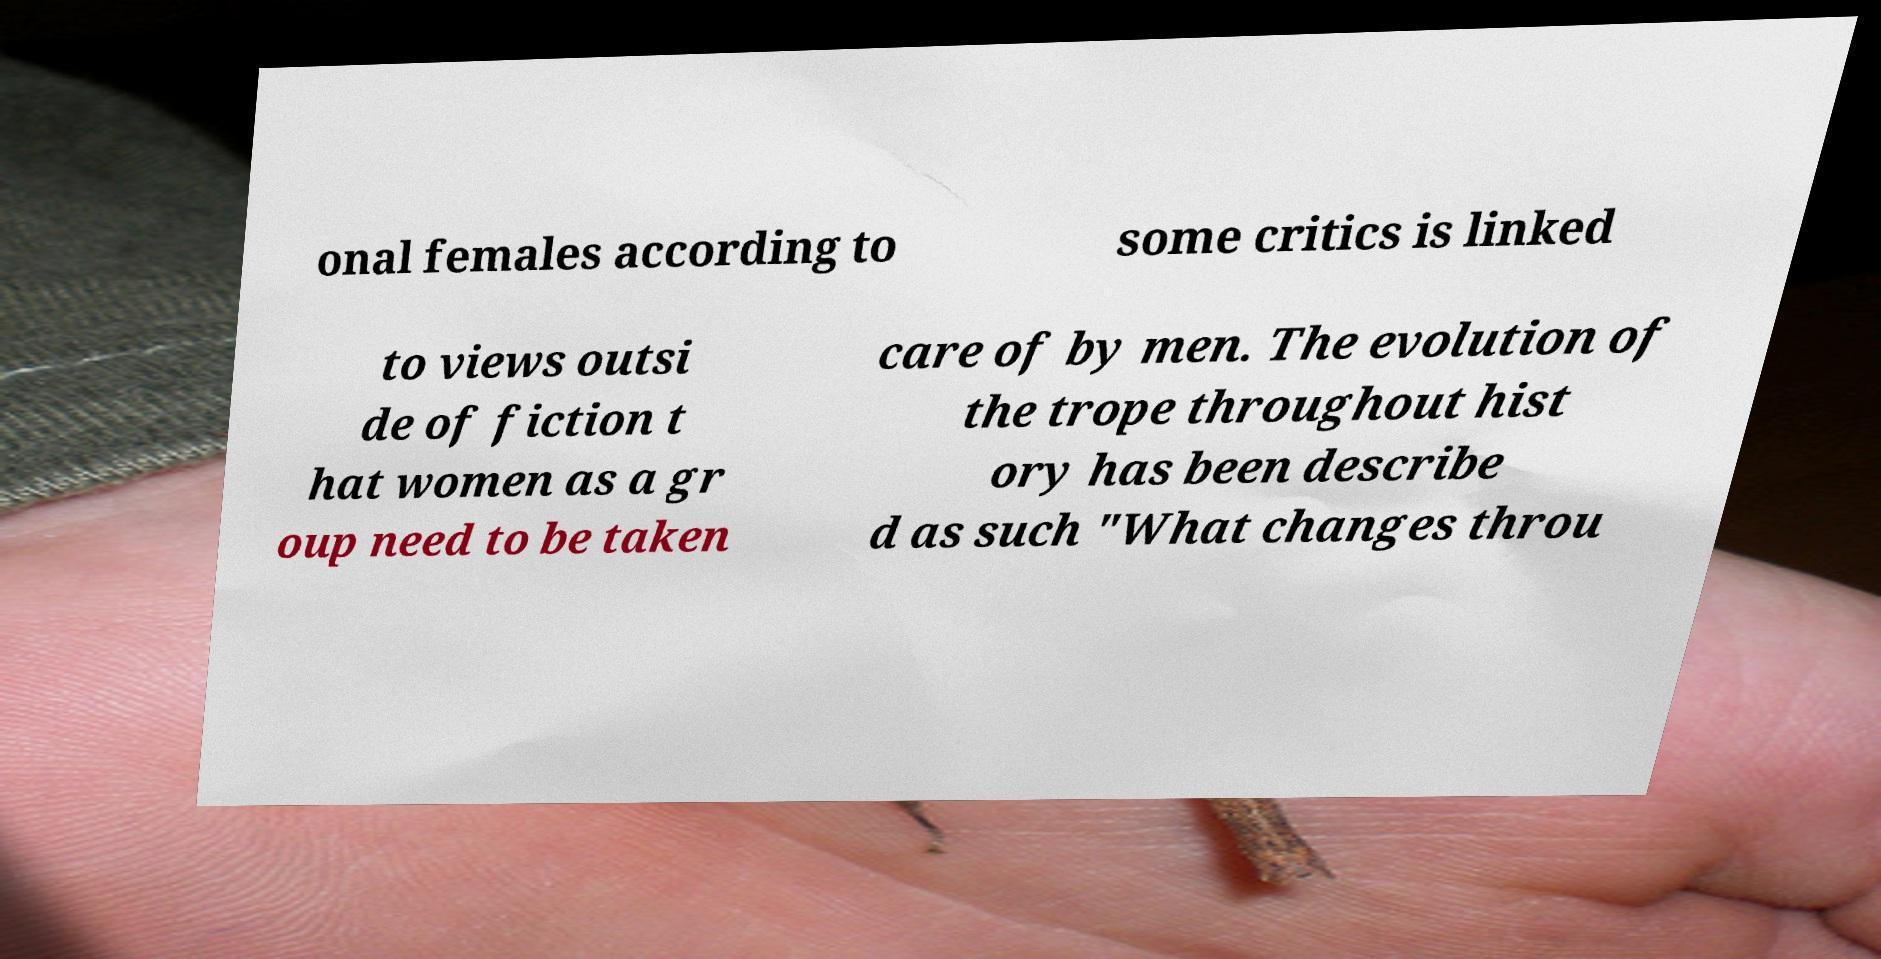Can you read and provide the text displayed in the image?This photo seems to have some interesting text. Can you extract and type it out for me? onal females according to some critics is linked to views outsi de of fiction t hat women as a gr oup need to be taken care of by men. The evolution of the trope throughout hist ory has been describe d as such "What changes throu 